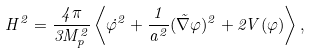Convert formula to latex. <formula><loc_0><loc_0><loc_500><loc_500>H ^ { 2 } = \frac { 4 \pi } { 3 M _ { p } ^ { 2 } } \left < \dot { \varphi } ^ { 2 } + \frac { 1 } { a ^ { 2 } } ( \vec { \nabla } \varphi ) ^ { 2 } + 2 V ( \varphi ) \right > ,</formula> 